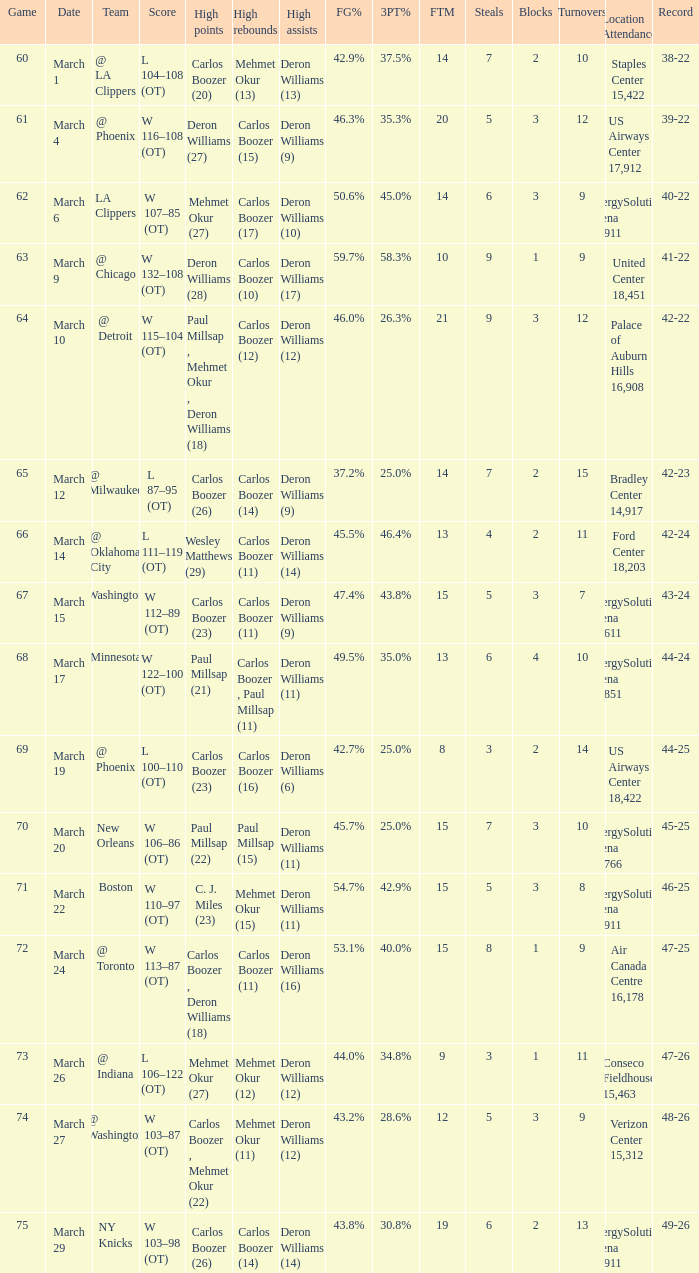Where was the March 24 game played? Air Canada Centre 16,178. 